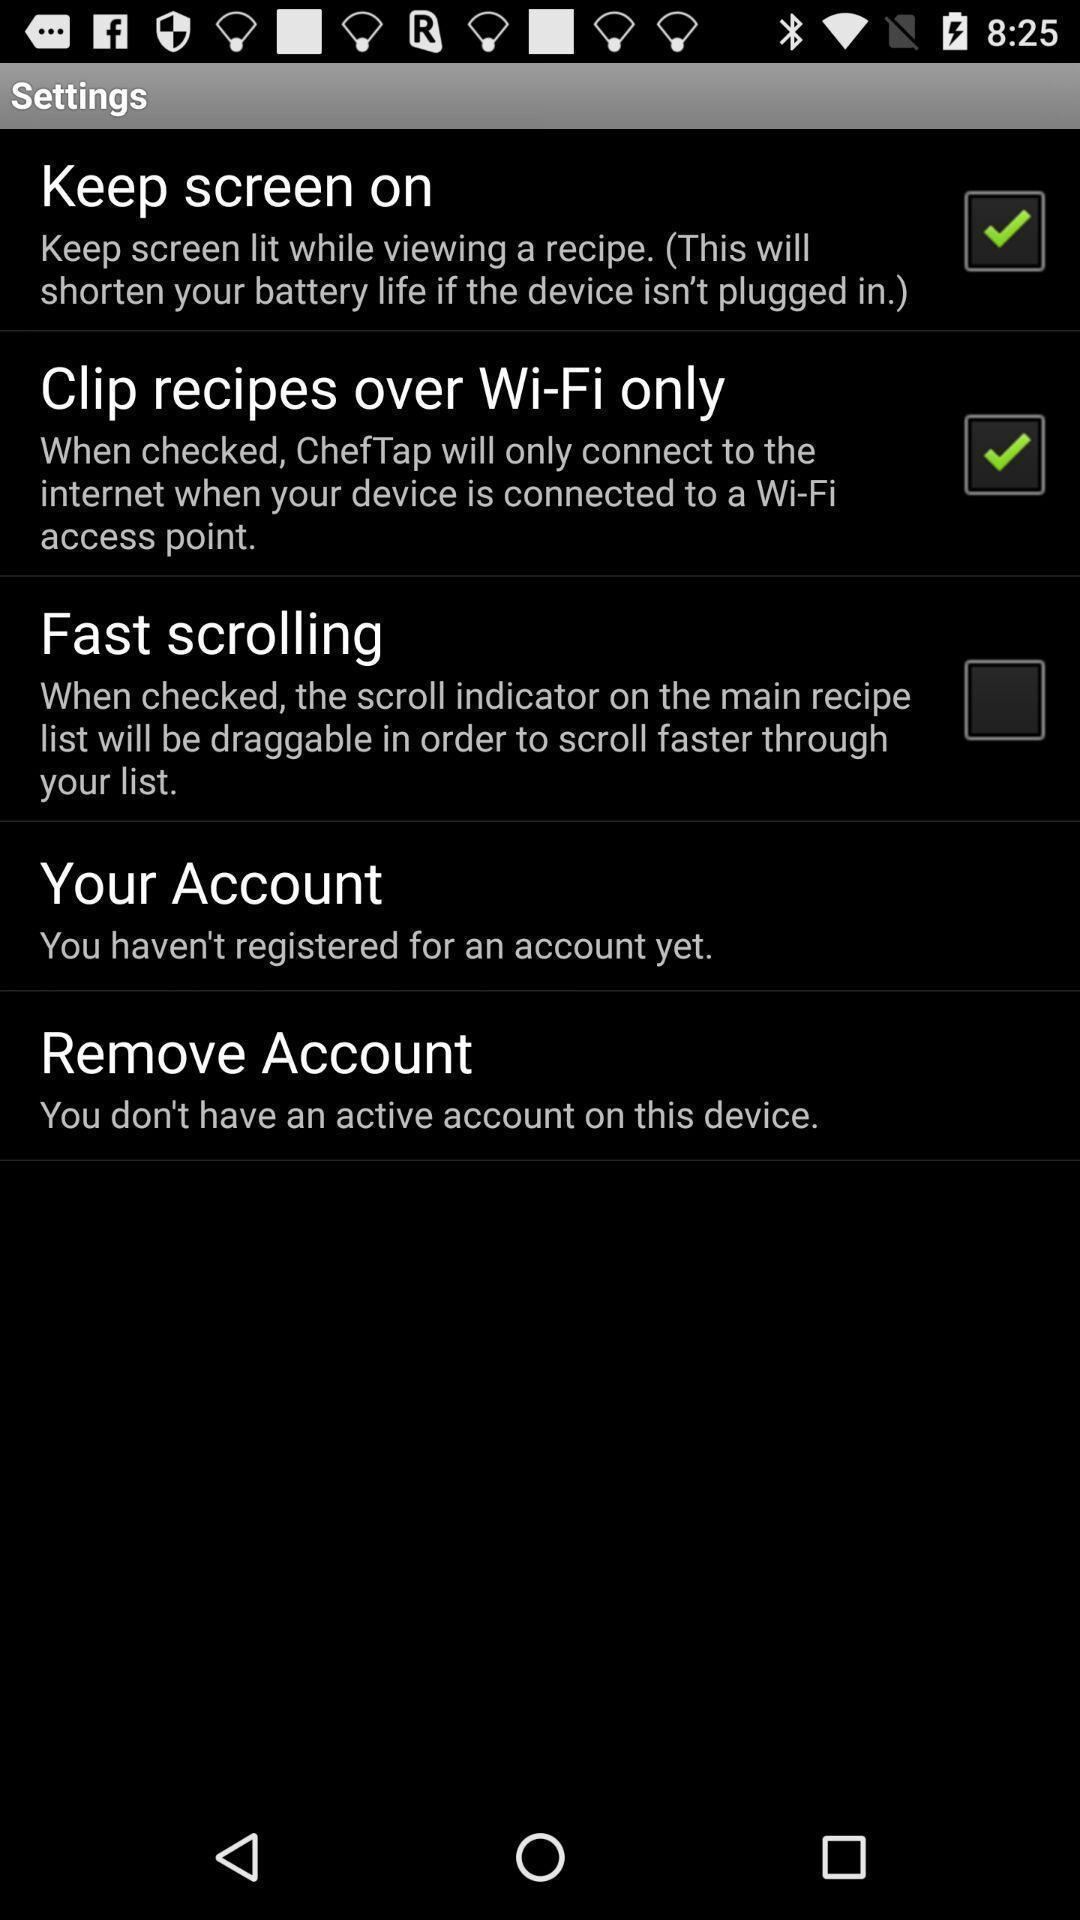Explain the elements present in this screenshot. Settings page with some options in cooking app. 